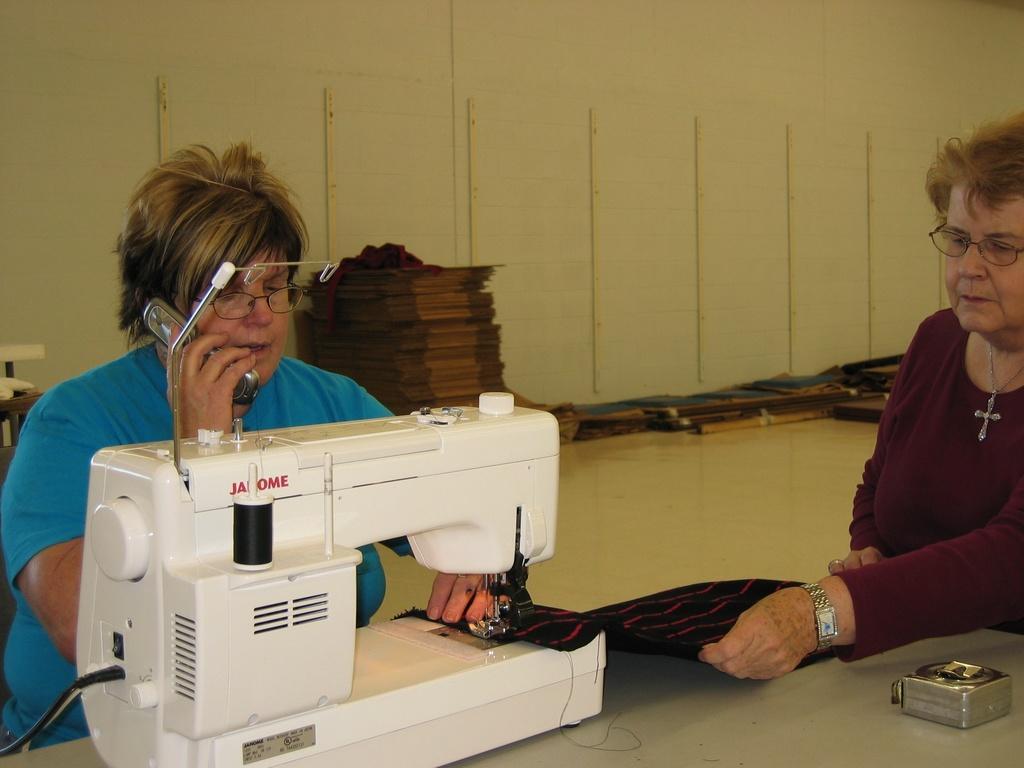How would you summarize this image in a sentence or two? To the left side of the image there is a lady holding a phone in her hand. In front of her there is a stitching machine on the table. To the right side of the image there is a lady. In the background of the image there is a wall. There are objects placed on the wall. 